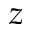<formula> <loc_0><loc_0><loc_500><loc_500>z</formula> 